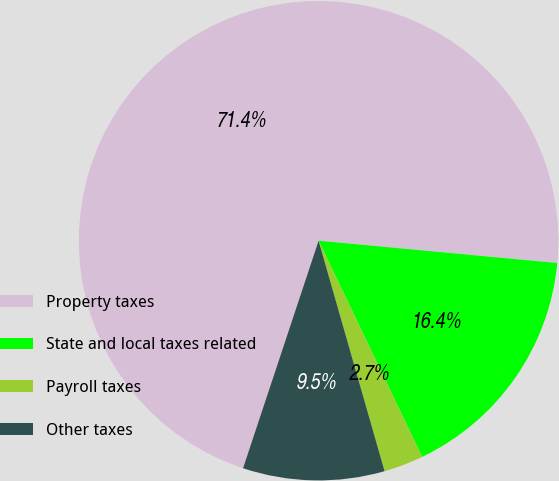Convert chart. <chart><loc_0><loc_0><loc_500><loc_500><pie_chart><fcel>Property taxes<fcel>State and local taxes related<fcel>Payroll taxes<fcel>Other taxes<nl><fcel>71.38%<fcel>16.41%<fcel>2.67%<fcel>9.54%<nl></chart> 